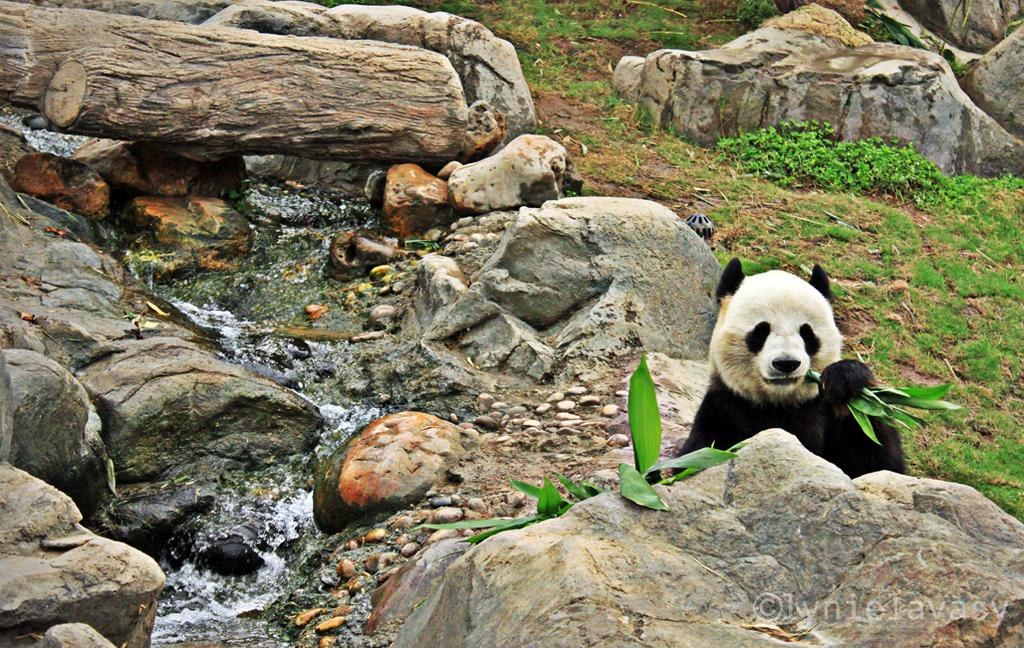What animal is present in the image? There is a panda in the image. What is the panda holding in the image? The panda is holding a leaf. What type of natural elements can be seen in the image? There are rocks, stones, water flow, plants, grass, and a tree trunk in the image. Where is the door located in the image? There is no door present in the image. What type of hydrant can be seen near the water flow in the image? There is no hydrant present in the image. 